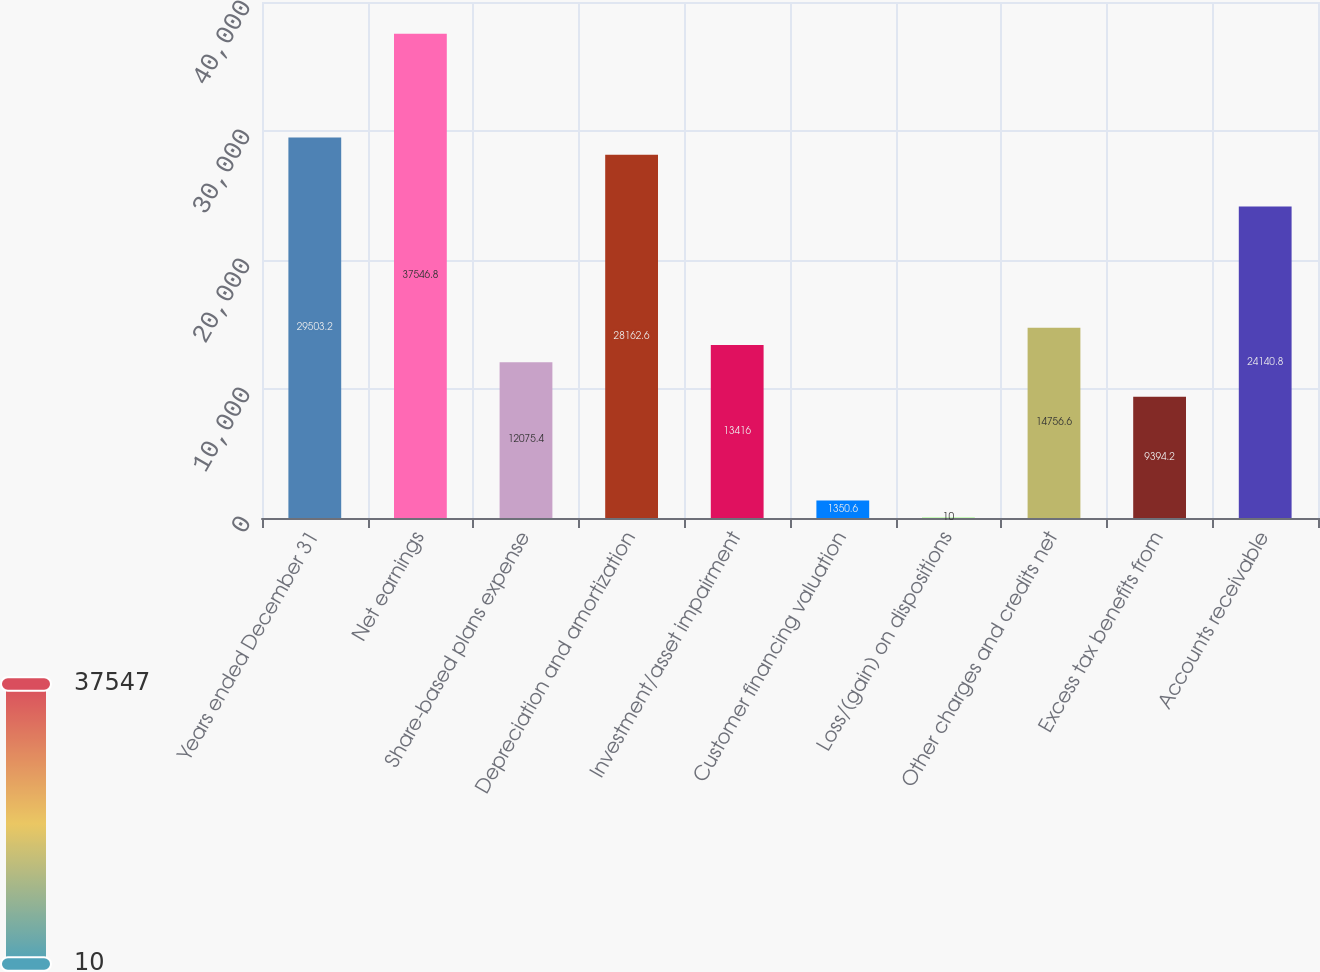<chart> <loc_0><loc_0><loc_500><loc_500><bar_chart><fcel>Years ended December 31<fcel>Net earnings<fcel>Share-based plans expense<fcel>Depreciation and amortization<fcel>Investment/asset impairment<fcel>Customer financing valuation<fcel>Loss/(gain) on dispositions<fcel>Other charges and credits net<fcel>Excess tax benefits from<fcel>Accounts receivable<nl><fcel>29503.2<fcel>37546.8<fcel>12075.4<fcel>28162.6<fcel>13416<fcel>1350.6<fcel>10<fcel>14756.6<fcel>9394.2<fcel>24140.8<nl></chart> 